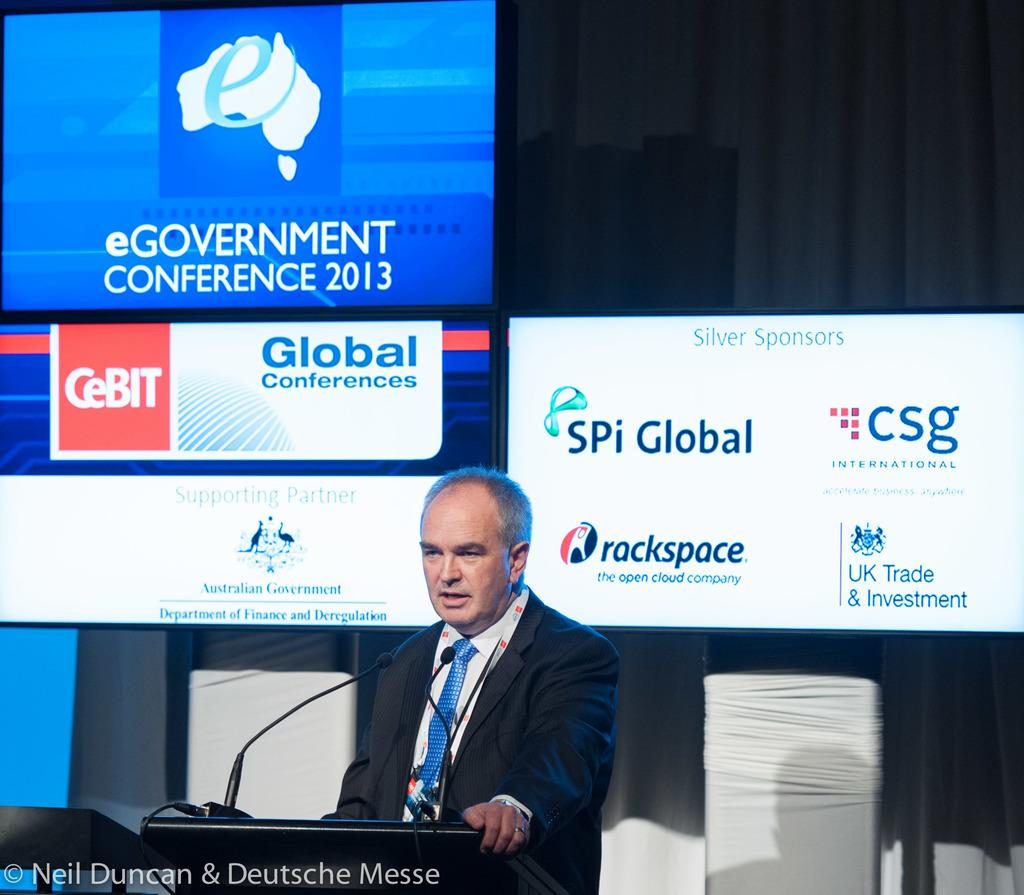Provide a one-sentence caption for the provided image. A man is talking behind a podium with several adverts behind him like spi global. 